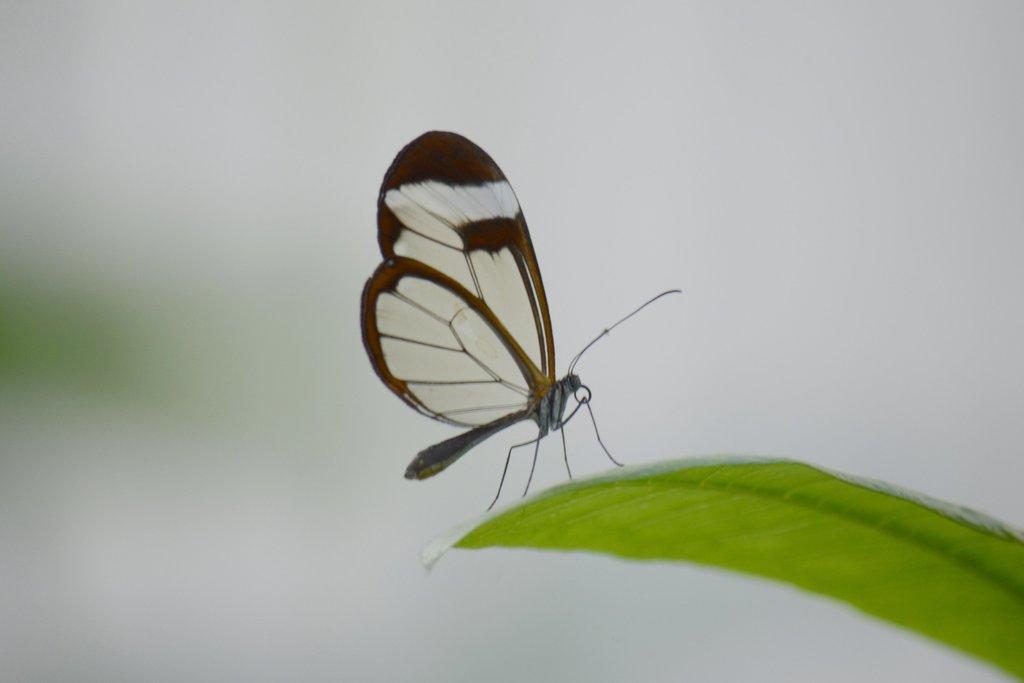Can you describe this image briefly? This picture contains a butterfly which is in white and brown color. This butterfly is on the green color leaf. In the background, it is white in color and it is blurred in the background. 